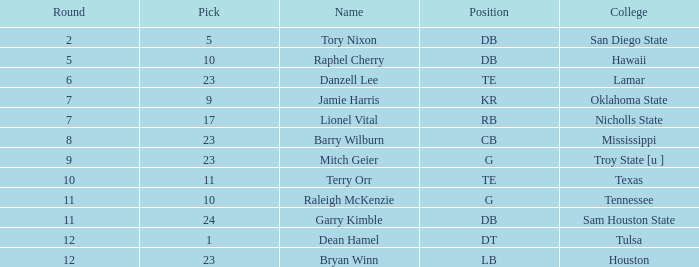How many options have a college of hawaii and a combined smaller than 122? 0.0. 